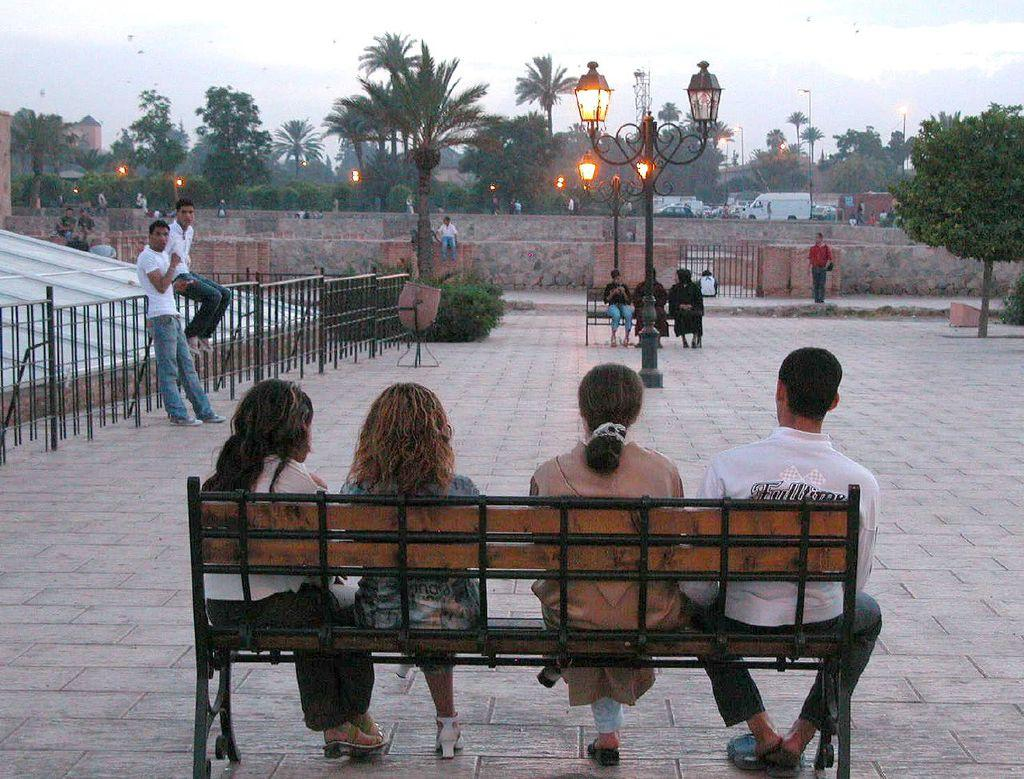What are the people in the image doing? There are persons standing and sitting in the image. What can be seen in the background of the image? There is a fence, trees, cars, and light poles in the image. What is the condition of the sky in the image? The sky is cloudy in the image. What is the chance of the angle of the mind being visible in the image? There is no mention of an angle, chance, or mind in the image, so it cannot be determined if they are visible. 